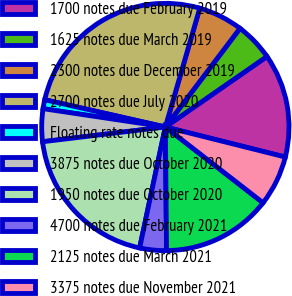Convert chart to OTSL. <chart><loc_0><loc_0><loc_500><loc_500><pie_chart><fcel>1700 notes due February 2019<fcel>1625 notes due March 2019<fcel>2300 notes due December 2019<fcel>2700 notes due July 2020<fcel>Floating rate notes due<fcel>3875 notes due October 2020<fcel>1950 notes due October 2020<fcel>4700 notes due February 2021<fcel>2125 notes due March 2021<fcel>3375 notes due November 2021<nl><fcel>13.56%<fcel>5.04%<fcel>5.82%<fcel>25.95%<fcel>1.17%<fcel>4.27%<fcel>19.76%<fcel>3.49%<fcel>14.34%<fcel>6.59%<nl></chart> 